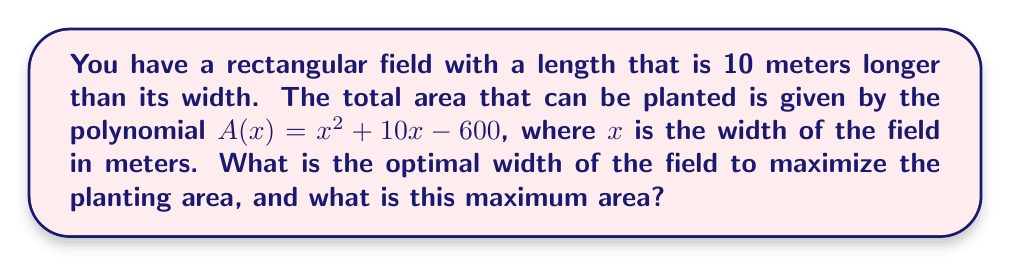Could you help me with this problem? 1. The polynomial $A(x) = x^2 + 10x - 600$ represents the area of the field.

2. To find the maximum area, we need to find the vertex of this parabola. The vertex represents the point where the area is maximized.

3. For a quadratic function in the form $f(x) = ax^2 + bx + c$, the x-coordinate of the vertex is given by $x = -\frac{b}{2a}$.

4. In our case, $a = 1$, $b = 10$, and $c = -600$.

5. Calculating the x-coordinate of the vertex:
   $x = -\frac{10}{2(1)} = -5$

6. The optimal width is the absolute value of this x-coordinate: 5 meters.

7. To find the maximum area, we substitute x = 5 into the original equation:
   $A(5) = 5^2 + 10(5) - 600$
   $= 25 + 50 - 600$
   $= -525$

8. The negative area doesn't make sense in real-world context, so we take the absolute value: 525 square meters.
Answer: Optimal width: 5 m; Maximum area: 525 m² 